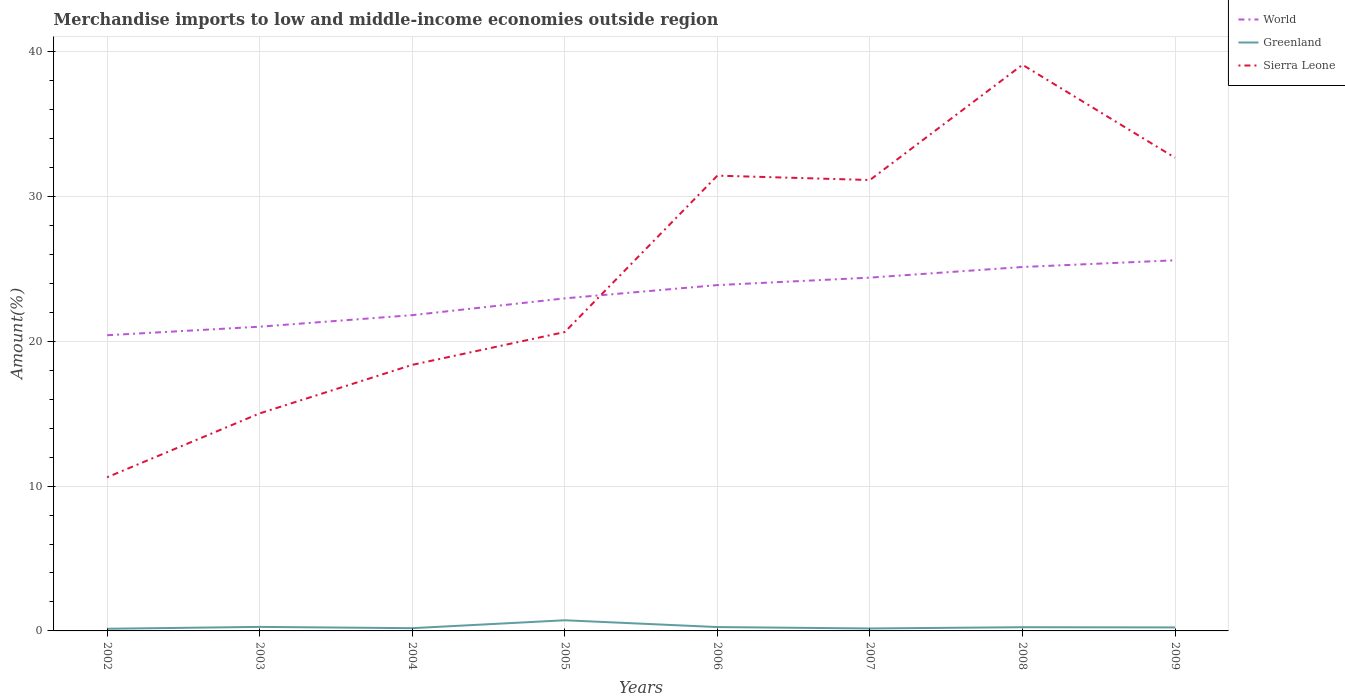Is the number of lines equal to the number of legend labels?
Keep it short and to the point. Yes. Across all years, what is the maximum percentage of amount earned from merchandise imports in World?
Offer a terse response. 20.41. What is the total percentage of amount earned from merchandise imports in World in the graph?
Give a very brief answer. -2.17. What is the difference between the highest and the second highest percentage of amount earned from merchandise imports in Sierra Leone?
Your response must be concise. 28.48. What is the difference between the highest and the lowest percentage of amount earned from merchandise imports in Sierra Leone?
Ensure brevity in your answer.  4. What is the difference between two consecutive major ticks on the Y-axis?
Your answer should be compact. 10. Does the graph contain any zero values?
Provide a short and direct response. No. Does the graph contain grids?
Provide a short and direct response. Yes. Where does the legend appear in the graph?
Give a very brief answer. Top right. How many legend labels are there?
Your answer should be very brief. 3. What is the title of the graph?
Provide a short and direct response. Merchandise imports to low and middle-income economies outside region. Does "Malawi" appear as one of the legend labels in the graph?
Offer a terse response. No. What is the label or title of the Y-axis?
Keep it short and to the point. Amount(%). What is the Amount(%) of World in 2002?
Provide a succinct answer. 20.41. What is the Amount(%) in Greenland in 2002?
Give a very brief answer. 0.15. What is the Amount(%) of Sierra Leone in 2002?
Provide a succinct answer. 10.61. What is the Amount(%) in World in 2003?
Make the answer very short. 21. What is the Amount(%) of Greenland in 2003?
Offer a terse response. 0.28. What is the Amount(%) in Sierra Leone in 2003?
Your response must be concise. 15.02. What is the Amount(%) of World in 2004?
Keep it short and to the point. 21.8. What is the Amount(%) of Greenland in 2004?
Offer a very short reply. 0.19. What is the Amount(%) of Sierra Leone in 2004?
Provide a succinct answer. 18.37. What is the Amount(%) in World in 2005?
Offer a very short reply. 22.96. What is the Amount(%) in Greenland in 2005?
Give a very brief answer. 0.74. What is the Amount(%) of Sierra Leone in 2005?
Provide a succinct answer. 20.64. What is the Amount(%) in World in 2006?
Your answer should be very brief. 23.88. What is the Amount(%) in Greenland in 2006?
Keep it short and to the point. 0.27. What is the Amount(%) in Sierra Leone in 2006?
Provide a short and direct response. 31.43. What is the Amount(%) of World in 2007?
Provide a short and direct response. 24.39. What is the Amount(%) in Greenland in 2007?
Ensure brevity in your answer.  0.17. What is the Amount(%) in Sierra Leone in 2007?
Offer a terse response. 31.13. What is the Amount(%) in World in 2008?
Keep it short and to the point. 25.13. What is the Amount(%) of Greenland in 2008?
Make the answer very short. 0.26. What is the Amount(%) of Sierra Leone in 2008?
Provide a succinct answer. 39.09. What is the Amount(%) of World in 2009?
Make the answer very short. 25.59. What is the Amount(%) of Greenland in 2009?
Provide a short and direct response. 0.24. What is the Amount(%) in Sierra Leone in 2009?
Your answer should be very brief. 32.67. Across all years, what is the maximum Amount(%) of World?
Your answer should be very brief. 25.59. Across all years, what is the maximum Amount(%) in Greenland?
Provide a succinct answer. 0.74. Across all years, what is the maximum Amount(%) in Sierra Leone?
Offer a very short reply. 39.09. Across all years, what is the minimum Amount(%) in World?
Your answer should be very brief. 20.41. Across all years, what is the minimum Amount(%) of Greenland?
Your answer should be very brief. 0.15. Across all years, what is the minimum Amount(%) of Sierra Leone?
Your response must be concise. 10.61. What is the total Amount(%) of World in the graph?
Your response must be concise. 185.16. What is the total Amount(%) in Greenland in the graph?
Ensure brevity in your answer.  2.29. What is the total Amount(%) in Sierra Leone in the graph?
Your response must be concise. 198.95. What is the difference between the Amount(%) of World in 2002 and that in 2003?
Your answer should be compact. -0.59. What is the difference between the Amount(%) of Greenland in 2002 and that in 2003?
Keep it short and to the point. -0.13. What is the difference between the Amount(%) in Sierra Leone in 2002 and that in 2003?
Give a very brief answer. -4.41. What is the difference between the Amount(%) of World in 2002 and that in 2004?
Offer a very short reply. -1.39. What is the difference between the Amount(%) of Greenland in 2002 and that in 2004?
Your answer should be compact. -0.04. What is the difference between the Amount(%) in Sierra Leone in 2002 and that in 2004?
Provide a short and direct response. -7.76. What is the difference between the Amount(%) in World in 2002 and that in 2005?
Your response must be concise. -2.55. What is the difference between the Amount(%) in Greenland in 2002 and that in 2005?
Your answer should be very brief. -0.59. What is the difference between the Amount(%) of Sierra Leone in 2002 and that in 2005?
Your answer should be very brief. -10.03. What is the difference between the Amount(%) of World in 2002 and that in 2006?
Make the answer very short. -3.46. What is the difference between the Amount(%) in Greenland in 2002 and that in 2006?
Provide a succinct answer. -0.12. What is the difference between the Amount(%) of Sierra Leone in 2002 and that in 2006?
Provide a succinct answer. -20.82. What is the difference between the Amount(%) in World in 2002 and that in 2007?
Give a very brief answer. -3.98. What is the difference between the Amount(%) in Greenland in 2002 and that in 2007?
Ensure brevity in your answer.  -0.02. What is the difference between the Amount(%) of Sierra Leone in 2002 and that in 2007?
Offer a terse response. -20.52. What is the difference between the Amount(%) of World in 2002 and that in 2008?
Keep it short and to the point. -4.71. What is the difference between the Amount(%) of Greenland in 2002 and that in 2008?
Keep it short and to the point. -0.11. What is the difference between the Amount(%) of Sierra Leone in 2002 and that in 2008?
Offer a terse response. -28.48. What is the difference between the Amount(%) in World in 2002 and that in 2009?
Keep it short and to the point. -5.18. What is the difference between the Amount(%) of Greenland in 2002 and that in 2009?
Provide a succinct answer. -0.09. What is the difference between the Amount(%) in Sierra Leone in 2002 and that in 2009?
Ensure brevity in your answer.  -22.06. What is the difference between the Amount(%) in World in 2003 and that in 2004?
Offer a terse response. -0.8. What is the difference between the Amount(%) of Greenland in 2003 and that in 2004?
Provide a succinct answer. 0.09. What is the difference between the Amount(%) in Sierra Leone in 2003 and that in 2004?
Ensure brevity in your answer.  -3.35. What is the difference between the Amount(%) of World in 2003 and that in 2005?
Offer a terse response. -1.96. What is the difference between the Amount(%) of Greenland in 2003 and that in 2005?
Your answer should be very brief. -0.46. What is the difference between the Amount(%) of Sierra Leone in 2003 and that in 2005?
Offer a terse response. -5.62. What is the difference between the Amount(%) of World in 2003 and that in 2006?
Give a very brief answer. -2.87. What is the difference between the Amount(%) of Greenland in 2003 and that in 2006?
Your answer should be very brief. 0.01. What is the difference between the Amount(%) of Sierra Leone in 2003 and that in 2006?
Ensure brevity in your answer.  -16.41. What is the difference between the Amount(%) of World in 2003 and that in 2007?
Your answer should be compact. -3.39. What is the difference between the Amount(%) of Greenland in 2003 and that in 2007?
Provide a succinct answer. 0.11. What is the difference between the Amount(%) in Sierra Leone in 2003 and that in 2007?
Offer a very short reply. -16.11. What is the difference between the Amount(%) of World in 2003 and that in 2008?
Give a very brief answer. -4.12. What is the difference between the Amount(%) in Greenland in 2003 and that in 2008?
Your answer should be compact. 0.02. What is the difference between the Amount(%) of Sierra Leone in 2003 and that in 2008?
Give a very brief answer. -24.07. What is the difference between the Amount(%) in World in 2003 and that in 2009?
Provide a short and direct response. -4.59. What is the difference between the Amount(%) in Greenland in 2003 and that in 2009?
Provide a succinct answer. 0.04. What is the difference between the Amount(%) in Sierra Leone in 2003 and that in 2009?
Make the answer very short. -17.65. What is the difference between the Amount(%) of World in 2004 and that in 2005?
Offer a terse response. -1.16. What is the difference between the Amount(%) of Greenland in 2004 and that in 2005?
Provide a short and direct response. -0.55. What is the difference between the Amount(%) in Sierra Leone in 2004 and that in 2005?
Give a very brief answer. -2.27. What is the difference between the Amount(%) in World in 2004 and that in 2006?
Keep it short and to the point. -2.08. What is the difference between the Amount(%) of Greenland in 2004 and that in 2006?
Offer a very short reply. -0.08. What is the difference between the Amount(%) of Sierra Leone in 2004 and that in 2006?
Provide a succinct answer. -13.06. What is the difference between the Amount(%) of World in 2004 and that in 2007?
Give a very brief answer. -2.59. What is the difference between the Amount(%) in Greenland in 2004 and that in 2007?
Offer a terse response. 0.02. What is the difference between the Amount(%) in Sierra Leone in 2004 and that in 2007?
Keep it short and to the point. -12.76. What is the difference between the Amount(%) of World in 2004 and that in 2008?
Keep it short and to the point. -3.33. What is the difference between the Amount(%) of Greenland in 2004 and that in 2008?
Ensure brevity in your answer.  -0.07. What is the difference between the Amount(%) in Sierra Leone in 2004 and that in 2008?
Give a very brief answer. -20.72. What is the difference between the Amount(%) of World in 2004 and that in 2009?
Ensure brevity in your answer.  -3.79. What is the difference between the Amount(%) of Greenland in 2004 and that in 2009?
Provide a succinct answer. -0.05. What is the difference between the Amount(%) of Sierra Leone in 2004 and that in 2009?
Provide a short and direct response. -14.3. What is the difference between the Amount(%) of World in 2005 and that in 2006?
Offer a terse response. -0.92. What is the difference between the Amount(%) in Greenland in 2005 and that in 2006?
Keep it short and to the point. 0.47. What is the difference between the Amount(%) of Sierra Leone in 2005 and that in 2006?
Ensure brevity in your answer.  -10.8. What is the difference between the Amount(%) in World in 2005 and that in 2007?
Give a very brief answer. -1.43. What is the difference between the Amount(%) in Greenland in 2005 and that in 2007?
Keep it short and to the point. 0.57. What is the difference between the Amount(%) of Sierra Leone in 2005 and that in 2007?
Provide a succinct answer. -10.5. What is the difference between the Amount(%) of World in 2005 and that in 2008?
Your answer should be compact. -2.17. What is the difference between the Amount(%) of Greenland in 2005 and that in 2008?
Make the answer very short. 0.48. What is the difference between the Amount(%) in Sierra Leone in 2005 and that in 2008?
Your response must be concise. -18.45. What is the difference between the Amount(%) in World in 2005 and that in 2009?
Your response must be concise. -2.63. What is the difference between the Amount(%) in Greenland in 2005 and that in 2009?
Provide a succinct answer. 0.49. What is the difference between the Amount(%) in Sierra Leone in 2005 and that in 2009?
Your answer should be very brief. -12.03. What is the difference between the Amount(%) of World in 2006 and that in 2007?
Your answer should be compact. -0.52. What is the difference between the Amount(%) in Greenland in 2006 and that in 2007?
Your response must be concise. 0.1. What is the difference between the Amount(%) of Sierra Leone in 2006 and that in 2007?
Your response must be concise. 0.3. What is the difference between the Amount(%) in World in 2006 and that in 2008?
Ensure brevity in your answer.  -1.25. What is the difference between the Amount(%) of Greenland in 2006 and that in 2008?
Ensure brevity in your answer.  0.01. What is the difference between the Amount(%) of Sierra Leone in 2006 and that in 2008?
Give a very brief answer. -7.66. What is the difference between the Amount(%) in World in 2006 and that in 2009?
Your answer should be very brief. -1.71. What is the difference between the Amount(%) of Greenland in 2006 and that in 2009?
Provide a short and direct response. 0.02. What is the difference between the Amount(%) in Sierra Leone in 2006 and that in 2009?
Provide a short and direct response. -1.24. What is the difference between the Amount(%) of World in 2007 and that in 2008?
Your response must be concise. -0.73. What is the difference between the Amount(%) of Greenland in 2007 and that in 2008?
Offer a terse response. -0.09. What is the difference between the Amount(%) of Sierra Leone in 2007 and that in 2008?
Keep it short and to the point. -7.96. What is the difference between the Amount(%) of World in 2007 and that in 2009?
Provide a short and direct response. -1.2. What is the difference between the Amount(%) of Greenland in 2007 and that in 2009?
Offer a very short reply. -0.07. What is the difference between the Amount(%) of Sierra Leone in 2007 and that in 2009?
Offer a very short reply. -1.54. What is the difference between the Amount(%) in World in 2008 and that in 2009?
Your answer should be very brief. -0.46. What is the difference between the Amount(%) of Greenland in 2008 and that in 2009?
Make the answer very short. 0.01. What is the difference between the Amount(%) of Sierra Leone in 2008 and that in 2009?
Provide a succinct answer. 6.42. What is the difference between the Amount(%) of World in 2002 and the Amount(%) of Greenland in 2003?
Ensure brevity in your answer.  20.14. What is the difference between the Amount(%) of World in 2002 and the Amount(%) of Sierra Leone in 2003?
Make the answer very short. 5.4. What is the difference between the Amount(%) in Greenland in 2002 and the Amount(%) in Sierra Leone in 2003?
Your answer should be compact. -14.87. What is the difference between the Amount(%) in World in 2002 and the Amount(%) in Greenland in 2004?
Your response must be concise. 20.22. What is the difference between the Amount(%) of World in 2002 and the Amount(%) of Sierra Leone in 2004?
Your answer should be very brief. 2.04. What is the difference between the Amount(%) of Greenland in 2002 and the Amount(%) of Sierra Leone in 2004?
Provide a short and direct response. -18.22. What is the difference between the Amount(%) of World in 2002 and the Amount(%) of Greenland in 2005?
Your response must be concise. 19.68. What is the difference between the Amount(%) in World in 2002 and the Amount(%) in Sierra Leone in 2005?
Make the answer very short. -0.22. What is the difference between the Amount(%) in Greenland in 2002 and the Amount(%) in Sierra Leone in 2005?
Keep it short and to the point. -20.49. What is the difference between the Amount(%) of World in 2002 and the Amount(%) of Greenland in 2006?
Your answer should be compact. 20.15. What is the difference between the Amount(%) of World in 2002 and the Amount(%) of Sierra Leone in 2006?
Provide a succinct answer. -11.02. What is the difference between the Amount(%) in Greenland in 2002 and the Amount(%) in Sierra Leone in 2006?
Make the answer very short. -31.28. What is the difference between the Amount(%) in World in 2002 and the Amount(%) in Greenland in 2007?
Your response must be concise. 20.24. What is the difference between the Amount(%) of World in 2002 and the Amount(%) of Sierra Leone in 2007?
Make the answer very short. -10.72. What is the difference between the Amount(%) of Greenland in 2002 and the Amount(%) of Sierra Leone in 2007?
Keep it short and to the point. -30.98. What is the difference between the Amount(%) in World in 2002 and the Amount(%) in Greenland in 2008?
Offer a very short reply. 20.16. What is the difference between the Amount(%) in World in 2002 and the Amount(%) in Sierra Leone in 2008?
Provide a succinct answer. -18.67. What is the difference between the Amount(%) in Greenland in 2002 and the Amount(%) in Sierra Leone in 2008?
Provide a short and direct response. -38.94. What is the difference between the Amount(%) in World in 2002 and the Amount(%) in Greenland in 2009?
Make the answer very short. 20.17. What is the difference between the Amount(%) of World in 2002 and the Amount(%) of Sierra Leone in 2009?
Your response must be concise. -12.26. What is the difference between the Amount(%) of Greenland in 2002 and the Amount(%) of Sierra Leone in 2009?
Keep it short and to the point. -32.52. What is the difference between the Amount(%) of World in 2003 and the Amount(%) of Greenland in 2004?
Offer a very short reply. 20.81. What is the difference between the Amount(%) in World in 2003 and the Amount(%) in Sierra Leone in 2004?
Ensure brevity in your answer.  2.63. What is the difference between the Amount(%) of Greenland in 2003 and the Amount(%) of Sierra Leone in 2004?
Your response must be concise. -18.09. What is the difference between the Amount(%) in World in 2003 and the Amount(%) in Greenland in 2005?
Ensure brevity in your answer.  20.27. What is the difference between the Amount(%) in World in 2003 and the Amount(%) in Sierra Leone in 2005?
Provide a short and direct response. 0.37. What is the difference between the Amount(%) in Greenland in 2003 and the Amount(%) in Sierra Leone in 2005?
Ensure brevity in your answer.  -20.36. What is the difference between the Amount(%) of World in 2003 and the Amount(%) of Greenland in 2006?
Your response must be concise. 20.74. What is the difference between the Amount(%) in World in 2003 and the Amount(%) in Sierra Leone in 2006?
Ensure brevity in your answer.  -10.43. What is the difference between the Amount(%) of Greenland in 2003 and the Amount(%) of Sierra Leone in 2006?
Offer a terse response. -31.15. What is the difference between the Amount(%) in World in 2003 and the Amount(%) in Greenland in 2007?
Keep it short and to the point. 20.83. What is the difference between the Amount(%) of World in 2003 and the Amount(%) of Sierra Leone in 2007?
Provide a succinct answer. -10.13. What is the difference between the Amount(%) of Greenland in 2003 and the Amount(%) of Sierra Leone in 2007?
Offer a terse response. -30.85. What is the difference between the Amount(%) in World in 2003 and the Amount(%) in Greenland in 2008?
Your response must be concise. 20.75. What is the difference between the Amount(%) of World in 2003 and the Amount(%) of Sierra Leone in 2008?
Make the answer very short. -18.08. What is the difference between the Amount(%) of Greenland in 2003 and the Amount(%) of Sierra Leone in 2008?
Ensure brevity in your answer.  -38.81. What is the difference between the Amount(%) of World in 2003 and the Amount(%) of Greenland in 2009?
Your answer should be very brief. 20.76. What is the difference between the Amount(%) in World in 2003 and the Amount(%) in Sierra Leone in 2009?
Provide a succinct answer. -11.67. What is the difference between the Amount(%) of Greenland in 2003 and the Amount(%) of Sierra Leone in 2009?
Your answer should be compact. -32.39. What is the difference between the Amount(%) of World in 2004 and the Amount(%) of Greenland in 2005?
Provide a short and direct response. 21.06. What is the difference between the Amount(%) in World in 2004 and the Amount(%) in Sierra Leone in 2005?
Offer a terse response. 1.16. What is the difference between the Amount(%) in Greenland in 2004 and the Amount(%) in Sierra Leone in 2005?
Offer a terse response. -20.45. What is the difference between the Amount(%) in World in 2004 and the Amount(%) in Greenland in 2006?
Offer a terse response. 21.53. What is the difference between the Amount(%) in World in 2004 and the Amount(%) in Sierra Leone in 2006?
Your response must be concise. -9.63. What is the difference between the Amount(%) in Greenland in 2004 and the Amount(%) in Sierra Leone in 2006?
Offer a terse response. -31.24. What is the difference between the Amount(%) of World in 2004 and the Amount(%) of Greenland in 2007?
Offer a terse response. 21.63. What is the difference between the Amount(%) in World in 2004 and the Amount(%) in Sierra Leone in 2007?
Offer a terse response. -9.33. What is the difference between the Amount(%) of Greenland in 2004 and the Amount(%) of Sierra Leone in 2007?
Give a very brief answer. -30.94. What is the difference between the Amount(%) in World in 2004 and the Amount(%) in Greenland in 2008?
Provide a succinct answer. 21.54. What is the difference between the Amount(%) in World in 2004 and the Amount(%) in Sierra Leone in 2008?
Give a very brief answer. -17.29. What is the difference between the Amount(%) of Greenland in 2004 and the Amount(%) of Sierra Leone in 2008?
Ensure brevity in your answer.  -38.9. What is the difference between the Amount(%) of World in 2004 and the Amount(%) of Greenland in 2009?
Provide a short and direct response. 21.56. What is the difference between the Amount(%) in World in 2004 and the Amount(%) in Sierra Leone in 2009?
Provide a short and direct response. -10.87. What is the difference between the Amount(%) of Greenland in 2004 and the Amount(%) of Sierra Leone in 2009?
Provide a short and direct response. -32.48. What is the difference between the Amount(%) in World in 2005 and the Amount(%) in Greenland in 2006?
Your response must be concise. 22.69. What is the difference between the Amount(%) in World in 2005 and the Amount(%) in Sierra Leone in 2006?
Offer a very short reply. -8.47. What is the difference between the Amount(%) of Greenland in 2005 and the Amount(%) of Sierra Leone in 2006?
Your response must be concise. -30.7. What is the difference between the Amount(%) of World in 2005 and the Amount(%) of Greenland in 2007?
Your answer should be very brief. 22.79. What is the difference between the Amount(%) in World in 2005 and the Amount(%) in Sierra Leone in 2007?
Make the answer very short. -8.17. What is the difference between the Amount(%) of Greenland in 2005 and the Amount(%) of Sierra Leone in 2007?
Your response must be concise. -30.39. What is the difference between the Amount(%) in World in 2005 and the Amount(%) in Greenland in 2008?
Give a very brief answer. 22.7. What is the difference between the Amount(%) of World in 2005 and the Amount(%) of Sierra Leone in 2008?
Offer a terse response. -16.13. What is the difference between the Amount(%) of Greenland in 2005 and the Amount(%) of Sierra Leone in 2008?
Ensure brevity in your answer.  -38.35. What is the difference between the Amount(%) in World in 2005 and the Amount(%) in Greenland in 2009?
Give a very brief answer. 22.72. What is the difference between the Amount(%) in World in 2005 and the Amount(%) in Sierra Leone in 2009?
Your answer should be very brief. -9.71. What is the difference between the Amount(%) of Greenland in 2005 and the Amount(%) of Sierra Leone in 2009?
Your answer should be compact. -31.93. What is the difference between the Amount(%) of World in 2006 and the Amount(%) of Greenland in 2007?
Provide a succinct answer. 23.71. What is the difference between the Amount(%) in World in 2006 and the Amount(%) in Sierra Leone in 2007?
Offer a very short reply. -7.26. What is the difference between the Amount(%) in Greenland in 2006 and the Amount(%) in Sierra Leone in 2007?
Give a very brief answer. -30.86. What is the difference between the Amount(%) of World in 2006 and the Amount(%) of Greenland in 2008?
Your answer should be compact. 23.62. What is the difference between the Amount(%) in World in 2006 and the Amount(%) in Sierra Leone in 2008?
Offer a very short reply. -15.21. What is the difference between the Amount(%) of Greenland in 2006 and the Amount(%) of Sierra Leone in 2008?
Offer a terse response. -38.82. What is the difference between the Amount(%) in World in 2006 and the Amount(%) in Greenland in 2009?
Make the answer very short. 23.63. What is the difference between the Amount(%) in World in 2006 and the Amount(%) in Sierra Leone in 2009?
Ensure brevity in your answer.  -8.79. What is the difference between the Amount(%) of Greenland in 2006 and the Amount(%) of Sierra Leone in 2009?
Offer a very short reply. -32.4. What is the difference between the Amount(%) of World in 2007 and the Amount(%) of Greenland in 2008?
Keep it short and to the point. 24.14. What is the difference between the Amount(%) of World in 2007 and the Amount(%) of Sierra Leone in 2008?
Your response must be concise. -14.7. What is the difference between the Amount(%) in Greenland in 2007 and the Amount(%) in Sierra Leone in 2008?
Provide a succinct answer. -38.92. What is the difference between the Amount(%) of World in 2007 and the Amount(%) of Greenland in 2009?
Make the answer very short. 24.15. What is the difference between the Amount(%) of World in 2007 and the Amount(%) of Sierra Leone in 2009?
Provide a succinct answer. -8.28. What is the difference between the Amount(%) of Greenland in 2007 and the Amount(%) of Sierra Leone in 2009?
Offer a terse response. -32.5. What is the difference between the Amount(%) in World in 2008 and the Amount(%) in Greenland in 2009?
Provide a succinct answer. 24.88. What is the difference between the Amount(%) in World in 2008 and the Amount(%) in Sierra Leone in 2009?
Offer a terse response. -7.54. What is the difference between the Amount(%) of Greenland in 2008 and the Amount(%) of Sierra Leone in 2009?
Provide a short and direct response. -32.41. What is the average Amount(%) of World per year?
Your answer should be very brief. 23.14. What is the average Amount(%) in Greenland per year?
Your response must be concise. 0.29. What is the average Amount(%) in Sierra Leone per year?
Make the answer very short. 24.87. In the year 2002, what is the difference between the Amount(%) of World and Amount(%) of Greenland?
Ensure brevity in your answer.  20.27. In the year 2002, what is the difference between the Amount(%) of World and Amount(%) of Sierra Leone?
Offer a terse response. 9.81. In the year 2002, what is the difference between the Amount(%) of Greenland and Amount(%) of Sierra Leone?
Offer a terse response. -10.46. In the year 2003, what is the difference between the Amount(%) in World and Amount(%) in Greenland?
Your answer should be very brief. 20.73. In the year 2003, what is the difference between the Amount(%) in World and Amount(%) in Sierra Leone?
Provide a short and direct response. 5.99. In the year 2003, what is the difference between the Amount(%) in Greenland and Amount(%) in Sierra Leone?
Offer a terse response. -14.74. In the year 2004, what is the difference between the Amount(%) in World and Amount(%) in Greenland?
Make the answer very short. 21.61. In the year 2004, what is the difference between the Amount(%) in World and Amount(%) in Sierra Leone?
Make the answer very short. 3.43. In the year 2004, what is the difference between the Amount(%) in Greenland and Amount(%) in Sierra Leone?
Your answer should be compact. -18.18. In the year 2005, what is the difference between the Amount(%) of World and Amount(%) of Greenland?
Provide a succinct answer. 22.22. In the year 2005, what is the difference between the Amount(%) in World and Amount(%) in Sierra Leone?
Offer a terse response. 2.32. In the year 2005, what is the difference between the Amount(%) of Greenland and Amount(%) of Sierra Leone?
Offer a very short reply. -19.9. In the year 2006, what is the difference between the Amount(%) of World and Amount(%) of Greenland?
Provide a succinct answer. 23.61. In the year 2006, what is the difference between the Amount(%) in World and Amount(%) in Sierra Leone?
Your answer should be very brief. -7.56. In the year 2006, what is the difference between the Amount(%) in Greenland and Amount(%) in Sierra Leone?
Offer a very short reply. -31.17. In the year 2007, what is the difference between the Amount(%) of World and Amount(%) of Greenland?
Offer a terse response. 24.22. In the year 2007, what is the difference between the Amount(%) of World and Amount(%) of Sierra Leone?
Ensure brevity in your answer.  -6.74. In the year 2007, what is the difference between the Amount(%) of Greenland and Amount(%) of Sierra Leone?
Provide a succinct answer. -30.96. In the year 2008, what is the difference between the Amount(%) of World and Amount(%) of Greenland?
Offer a terse response. 24.87. In the year 2008, what is the difference between the Amount(%) of World and Amount(%) of Sierra Leone?
Offer a very short reply. -13.96. In the year 2008, what is the difference between the Amount(%) of Greenland and Amount(%) of Sierra Leone?
Offer a very short reply. -38.83. In the year 2009, what is the difference between the Amount(%) in World and Amount(%) in Greenland?
Make the answer very short. 25.35. In the year 2009, what is the difference between the Amount(%) in World and Amount(%) in Sierra Leone?
Keep it short and to the point. -7.08. In the year 2009, what is the difference between the Amount(%) of Greenland and Amount(%) of Sierra Leone?
Your answer should be compact. -32.43. What is the ratio of the Amount(%) of World in 2002 to that in 2003?
Provide a succinct answer. 0.97. What is the ratio of the Amount(%) in Greenland in 2002 to that in 2003?
Your response must be concise. 0.54. What is the ratio of the Amount(%) of Sierra Leone in 2002 to that in 2003?
Ensure brevity in your answer.  0.71. What is the ratio of the Amount(%) in World in 2002 to that in 2004?
Offer a terse response. 0.94. What is the ratio of the Amount(%) of Greenland in 2002 to that in 2004?
Your answer should be very brief. 0.78. What is the ratio of the Amount(%) of Sierra Leone in 2002 to that in 2004?
Provide a succinct answer. 0.58. What is the ratio of the Amount(%) in World in 2002 to that in 2005?
Give a very brief answer. 0.89. What is the ratio of the Amount(%) of Greenland in 2002 to that in 2005?
Offer a terse response. 0.2. What is the ratio of the Amount(%) in Sierra Leone in 2002 to that in 2005?
Your response must be concise. 0.51. What is the ratio of the Amount(%) in World in 2002 to that in 2006?
Offer a very short reply. 0.85. What is the ratio of the Amount(%) in Greenland in 2002 to that in 2006?
Your response must be concise. 0.56. What is the ratio of the Amount(%) in Sierra Leone in 2002 to that in 2006?
Give a very brief answer. 0.34. What is the ratio of the Amount(%) in World in 2002 to that in 2007?
Keep it short and to the point. 0.84. What is the ratio of the Amount(%) in Greenland in 2002 to that in 2007?
Give a very brief answer. 0.88. What is the ratio of the Amount(%) in Sierra Leone in 2002 to that in 2007?
Keep it short and to the point. 0.34. What is the ratio of the Amount(%) in World in 2002 to that in 2008?
Offer a terse response. 0.81. What is the ratio of the Amount(%) of Greenland in 2002 to that in 2008?
Your answer should be very brief. 0.58. What is the ratio of the Amount(%) of Sierra Leone in 2002 to that in 2008?
Keep it short and to the point. 0.27. What is the ratio of the Amount(%) in World in 2002 to that in 2009?
Offer a very short reply. 0.8. What is the ratio of the Amount(%) in Greenland in 2002 to that in 2009?
Offer a very short reply. 0.61. What is the ratio of the Amount(%) of Sierra Leone in 2002 to that in 2009?
Ensure brevity in your answer.  0.32. What is the ratio of the Amount(%) in World in 2003 to that in 2004?
Ensure brevity in your answer.  0.96. What is the ratio of the Amount(%) of Greenland in 2003 to that in 2004?
Provide a short and direct response. 1.46. What is the ratio of the Amount(%) of Sierra Leone in 2003 to that in 2004?
Your response must be concise. 0.82. What is the ratio of the Amount(%) of World in 2003 to that in 2005?
Provide a short and direct response. 0.91. What is the ratio of the Amount(%) of Greenland in 2003 to that in 2005?
Your answer should be compact. 0.38. What is the ratio of the Amount(%) in Sierra Leone in 2003 to that in 2005?
Provide a short and direct response. 0.73. What is the ratio of the Amount(%) in World in 2003 to that in 2006?
Your response must be concise. 0.88. What is the ratio of the Amount(%) in Greenland in 2003 to that in 2006?
Give a very brief answer. 1.04. What is the ratio of the Amount(%) of Sierra Leone in 2003 to that in 2006?
Your answer should be compact. 0.48. What is the ratio of the Amount(%) of World in 2003 to that in 2007?
Your answer should be compact. 0.86. What is the ratio of the Amount(%) of Greenland in 2003 to that in 2007?
Your answer should be very brief. 1.64. What is the ratio of the Amount(%) of Sierra Leone in 2003 to that in 2007?
Provide a short and direct response. 0.48. What is the ratio of the Amount(%) of World in 2003 to that in 2008?
Your answer should be compact. 0.84. What is the ratio of the Amount(%) of Greenland in 2003 to that in 2008?
Ensure brevity in your answer.  1.08. What is the ratio of the Amount(%) in Sierra Leone in 2003 to that in 2008?
Make the answer very short. 0.38. What is the ratio of the Amount(%) of World in 2003 to that in 2009?
Your answer should be compact. 0.82. What is the ratio of the Amount(%) in Greenland in 2003 to that in 2009?
Give a very brief answer. 1.15. What is the ratio of the Amount(%) of Sierra Leone in 2003 to that in 2009?
Provide a short and direct response. 0.46. What is the ratio of the Amount(%) of World in 2004 to that in 2005?
Offer a terse response. 0.95. What is the ratio of the Amount(%) of Greenland in 2004 to that in 2005?
Offer a very short reply. 0.26. What is the ratio of the Amount(%) in Sierra Leone in 2004 to that in 2005?
Offer a terse response. 0.89. What is the ratio of the Amount(%) in World in 2004 to that in 2006?
Offer a terse response. 0.91. What is the ratio of the Amount(%) of Greenland in 2004 to that in 2006?
Your answer should be very brief. 0.71. What is the ratio of the Amount(%) of Sierra Leone in 2004 to that in 2006?
Offer a very short reply. 0.58. What is the ratio of the Amount(%) of World in 2004 to that in 2007?
Provide a succinct answer. 0.89. What is the ratio of the Amount(%) of Greenland in 2004 to that in 2007?
Give a very brief answer. 1.12. What is the ratio of the Amount(%) of Sierra Leone in 2004 to that in 2007?
Offer a very short reply. 0.59. What is the ratio of the Amount(%) of World in 2004 to that in 2008?
Offer a very short reply. 0.87. What is the ratio of the Amount(%) of Greenland in 2004 to that in 2008?
Your answer should be compact. 0.74. What is the ratio of the Amount(%) in Sierra Leone in 2004 to that in 2008?
Ensure brevity in your answer.  0.47. What is the ratio of the Amount(%) of World in 2004 to that in 2009?
Provide a succinct answer. 0.85. What is the ratio of the Amount(%) in Greenland in 2004 to that in 2009?
Your answer should be very brief. 0.79. What is the ratio of the Amount(%) of Sierra Leone in 2004 to that in 2009?
Keep it short and to the point. 0.56. What is the ratio of the Amount(%) in World in 2005 to that in 2006?
Provide a succinct answer. 0.96. What is the ratio of the Amount(%) of Greenland in 2005 to that in 2006?
Keep it short and to the point. 2.76. What is the ratio of the Amount(%) of Sierra Leone in 2005 to that in 2006?
Ensure brevity in your answer.  0.66. What is the ratio of the Amount(%) in World in 2005 to that in 2007?
Provide a short and direct response. 0.94. What is the ratio of the Amount(%) of Greenland in 2005 to that in 2007?
Give a very brief answer. 4.35. What is the ratio of the Amount(%) in Sierra Leone in 2005 to that in 2007?
Your answer should be compact. 0.66. What is the ratio of the Amount(%) of World in 2005 to that in 2008?
Your response must be concise. 0.91. What is the ratio of the Amount(%) of Greenland in 2005 to that in 2008?
Provide a short and direct response. 2.87. What is the ratio of the Amount(%) in Sierra Leone in 2005 to that in 2008?
Your response must be concise. 0.53. What is the ratio of the Amount(%) of World in 2005 to that in 2009?
Your answer should be very brief. 0.9. What is the ratio of the Amount(%) of Greenland in 2005 to that in 2009?
Your answer should be compact. 3.04. What is the ratio of the Amount(%) in Sierra Leone in 2005 to that in 2009?
Offer a terse response. 0.63. What is the ratio of the Amount(%) in World in 2006 to that in 2007?
Make the answer very short. 0.98. What is the ratio of the Amount(%) in Greenland in 2006 to that in 2007?
Make the answer very short. 1.57. What is the ratio of the Amount(%) in Sierra Leone in 2006 to that in 2007?
Make the answer very short. 1.01. What is the ratio of the Amount(%) of World in 2006 to that in 2008?
Provide a succinct answer. 0.95. What is the ratio of the Amount(%) in Greenland in 2006 to that in 2008?
Keep it short and to the point. 1.04. What is the ratio of the Amount(%) of Sierra Leone in 2006 to that in 2008?
Your answer should be compact. 0.8. What is the ratio of the Amount(%) of World in 2006 to that in 2009?
Ensure brevity in your answer.  0.93. What is the ratio of the Amount(%) of Greenland in 2006 to that in 2009?
Make the answer very short. 1.1. What is the ratio of the Amount(%) of Sierra Leone in 2006 to that in 2009?
Give a very brief answer. 0.96. What is the ratio of the Amount(%) in World in 2007 to that in 2008?
Offer a terse response. 0.97. What is the ratio of the Amount(%) of Greenland in 2007 to that in 2008?
Offer a very short reply. 0.66. What is the ratio of the Amount(%) in Sierra Leone in 2007 to that in 2008?
Give a very brief answer. 0.8. What is the ratio of the Amount(%) in World in 2007 to that in 2009?
Ensure brevity in your answer.  0.95. What is the ratio of the Amount(%) of Greenland in 2007 to that in 2009?
Ensure brevity in your answer.  0.7. What is the ratio of the Amount(%) of Sierra Leone in 2007 to that in 2009?
Make the answer very short. 0.95. What is the ratio of the Amount(%) of World in 2008 to that in 2009?
Give a very brief answer. 0.98. What is the ratio of the Amount(%) of Greenland in 2008 to that in 2009?
Ensure brevity in your answer.  1.06. What is the ratio of the Amount(%) of Sierra Leone in 2008 to that in 2009?
Offer a very short reply. 1.2. What is the difference between the highest and the second highest Amount(%) in World?
Make the answer very short. 0.46. What is the difference between the highest and the second highest Amount(%) in Greenland?
Provide a short and direct response. 0.46. What is the difference between the highest and the second highest Amount(%) in Sierra Leone?
Your answer should be compact. 6.42. What is the difference between the highest and the lowest Amount(%) in World?
Ensure brevity in your answer.  5.18. What is the difference between the highest and the lowest Amount(%) in Greenland?
Offer a very short reply. 0.59. What is the difference between the highest and the lowest Amount(%) of Sierra Leone?
Give a very brief answer. 28.48. 